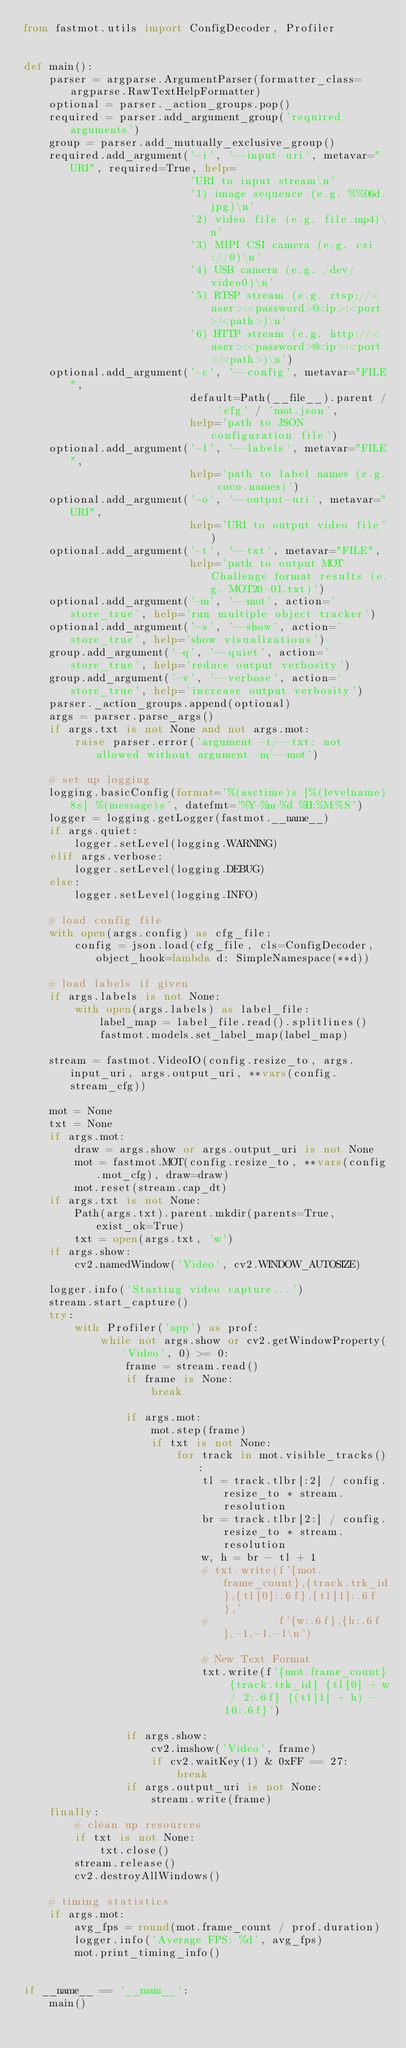Convert code to text. <code><loc_0><loc_0><loc_500><loc_500><_Python_>from fastmot.utils import ConfigDecoder, Profiler


def main():
    parser = argparse.ArgumentParser(formatter_class=argparse.RawTextHelpFormatter)
    optional = parser._action_groups.pop()
    required = parser.add_argument_group('required arguments')
    group = parser.add_mutually_exclusive_group()
    required.add_argument('-i', '--input-uri', metavar="URI", required=True, help=
                          'URI to input stream\n'
                          '1) image sequence (e.g. %%06d.jpg)\n'
                          '2) video file (e.g. file.mp4)\n'
                          '3) MIPI CSI camera (e.g. csi://0)\n'
                          '4) USB camera (e.g. /dev/video0)\n'
                          '5) RTSP stream (e.g. rtsp://<user>:<password>@<ip>:<port>/<path>)\n'
                          '6) HTTP stream (e.g. http://<user>:<password>@<ip>:<port>/<path>)\n')
    optional.add_argument('-c', '--config', metavar="FILE",
                          default=Path(__file__).parent / 'cfg' / 'mot.json',
                          help='path to JSON configuration file')
    optional.add_argument('-l', '--labels', metavar="FILE",
                          help='path to label names (e.g. coco.names)')
    optional.add_argument('-o', '--output-uri', metavar="URI",
                          help='URI to output video file')
    optional.add_argument('-t', '--txt', metavar="FILE",
                          help='path to output MOT Challenge format results (e.g. MOT20-01.txt)')
    optional.add_argument('-m', '--mot', action='store_true', help='run multiple object tracker')
    optional.add_argument('-s', '--show', action='store_true', help='show visualizations')
    group.add_argument('-q', '--quiet', action='store_true', help='reduce output verbosity')
    group.add_argument('-v', '--verbose', action='store_true', help='increase output verbosity')
    parser._action_groups.append(optional)
    args = parser.parse_args()
    if args.txt is not None and not args.mot:
        raise parser.error('argument -t/--txt: not allowed without argument -m/--mot')

    # set up logging
    logging.basicConfig(format='%(asctime)s [%(levelname)8s] %(message)s', datefmt='%Y-%m-%d %H:%M:%S')
    logger = logging.getLogger(fastmot.__name__)
    if args.quiet:
        logger.setLevel(logging.WARNING)
    elif args.verbose:
        logger.setLevel(logging.DEBUG)
    else:
        logger.setLevel(logging.INFO)

    # load config file
    with open(args.config) as cfg_file:
        config = json.load(cfg_file, cls=ConfigDecoder, object_hook=lambda d: SimpleNamespace(**d))

    # load labels if given
    if args.labels is not None:
        with open(args.labels) as label_file:
            label_map = label_file.read().splitlines()
            fastmot.models.set_label_map(label_map)

    stream = fastmot.VideoIO(config.resize_to, args.input_uri, args.output_uri, **vars(config.stream_cfg))

    mot = None
    txt = None
    if args.mot:
        draw = args.show or args.output_uri is not None
        mot = fastmot.MOT(config.resize_to, **vars(config.mot_cfg), draw=draw)
        mot.reset(stream.cap_dt)
    if args.txt is not None:
        Path(args.txt).parent.mkdir(parents=True, exist_ok=True)
        txt = open(args.txt, 'w')
    if args.show:
        cv2.namedWindow('Video', cv2.WINDOW_AUTOSIZE)

    logger.info('Starting video capture...')
    stream.start_capture()
    try:
        with Profiler('app') as prof:
            while not args.show or cv2.getWindowProperty('Video', 0) >= 0:
                frame = stream.read()
                if frame is None:
                    break

                if args.mot:
                    mot.step(frame)
                    if txt is not None:
                        for track in mot.visible_tracks():
                            tl = track.tlbr[:2] / config.resize_to * stream.resolution
                            br = track.tlbr[2:] / config.resize_to * stream.resolution
                            w, h = br - tl + 1
                            # txt.write(f'{mot.frame_count},{track.trk_id},{tl[0]:.6f},{tl[1]:.6f},'
                            #           f'{w:.6f},{h:.6f},-1,-1,-1\n')

                            # New Text Format 
                            txt.write(f'{mot.frame_count} {track.trk_id} {tl[0] + w / 2:.6f} {(tl[1] + h) - 10:.6f}')

                if args.show:
                    cv2.imshow('Video', frame)
                    if cv2.waitKey(1) & 0xFF == 27:
                        break
                if args.output_uri is not None:
                    stream.write(frame)
    finally:
        # clean up resources
        if txt is not None:
            txt.close()
        stream.release()
        cv2.destroyAllWindows()

    # timing statistics
    if args.mot:
        avg_fps = round(mot.frame_count / prof.duration)
        logger.info('Average FPS: %d', avg_fps)
        mot.print_timing_info()


if __name__ == '__main__':
    main()
</code> 